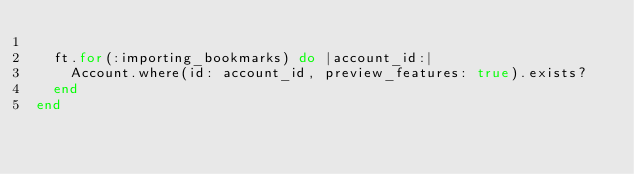Convert code to text. <code><loc_0><loc_0><loc_500><loc_500><_Ruby_>
  ft.for(:importing_bookmarks) do |account_id:|
    Account.where(id: account_id, preview_features: true).exists?
  end
end
</code> 